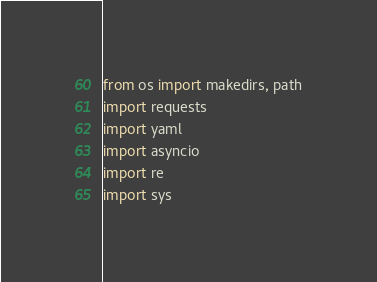Convert code to text. <code><loc_0><loc_0><loc_500><loc_500><_Python_>from os import makedirs, path
import requests
import yaml
import asyncio
import re
import sys
</code> 